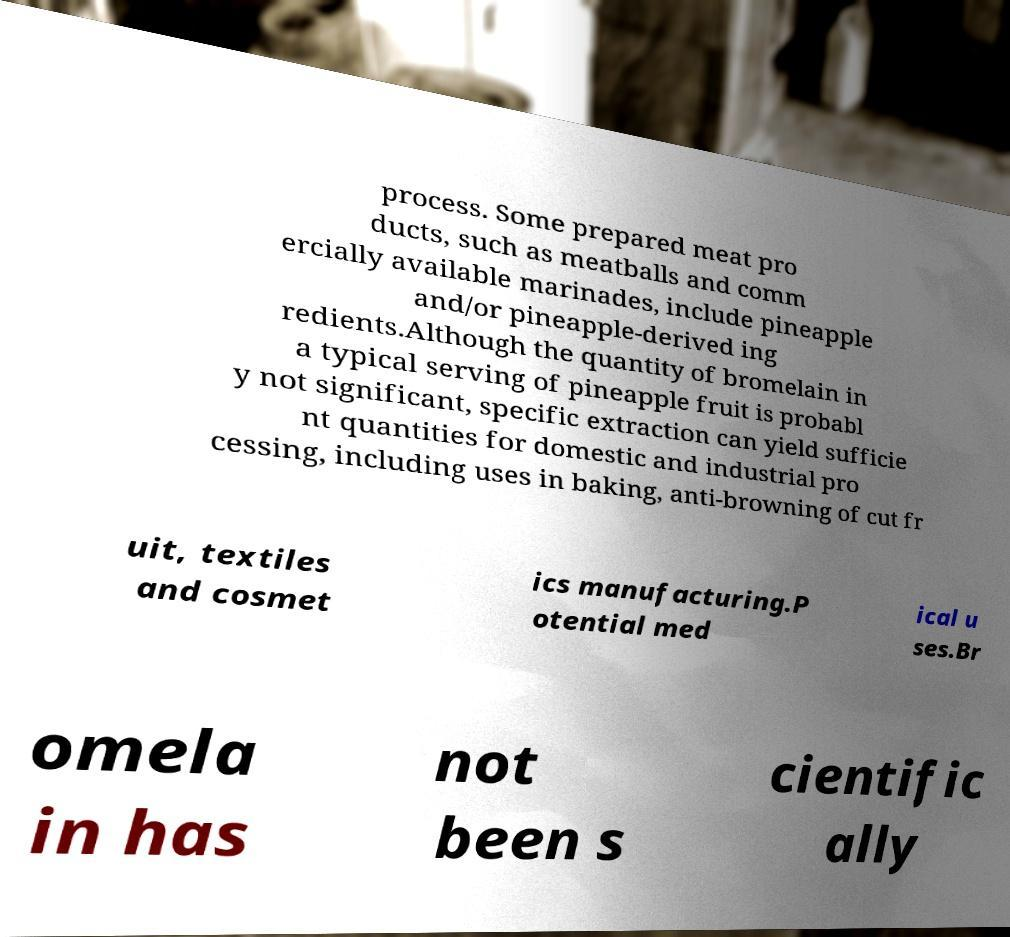Could you extract and type out the text from this image? process. Some prepared meat pro ducts, such as meatballs and comm ercially available marinades, include pineapple and/or pineapple-derived ing redients.Although the quantity of bromelain in a typical serving of pineapple fruit is probabl y not significant, specific extraction can yield sufficie nt quantities for domestic and industrial pro cessing, including uses in baking, anti-browning of cut fr uit, textiles and cosmet ics manufacturing.P otential med ical u ses.Br omela in has not been s cientific ally 